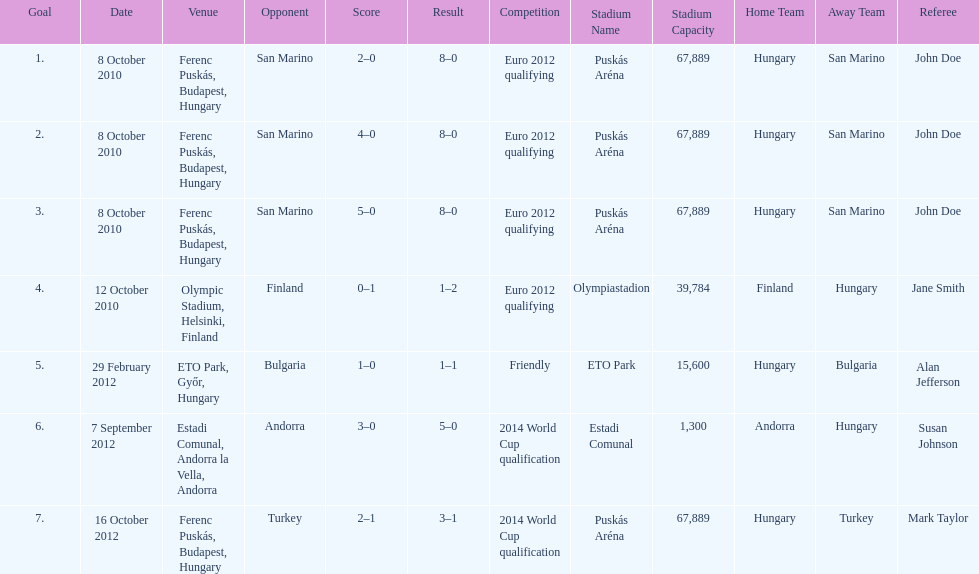How many games did he score but his team lost? 1. 